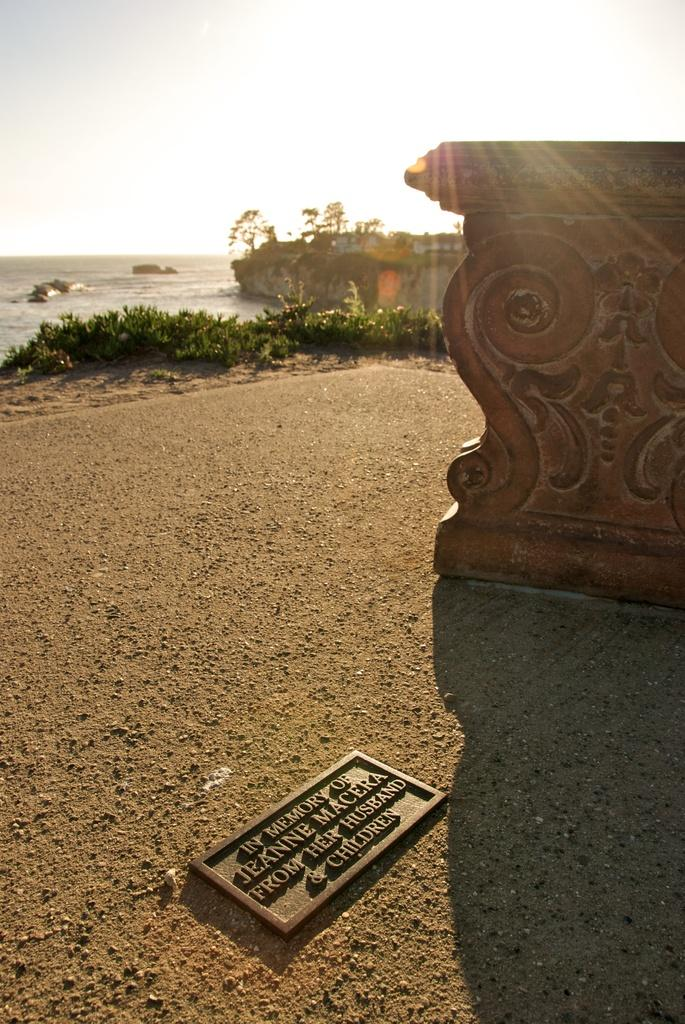What is on the ground in the image? There is a board on the ground in the image. What can be seen in the background of the image? The sky is sunny and visible in the background of the image. What type of vegetation is present in the image? There are plants in the image. What else can be seen in the image besides the board and plants? There is a wall, water, and stones visible in the image. What type of gun is being used by the plant in the image? There is no gun present in the image; it features a board, wall, plants, water, stones, and a sunny sky. How does the head of the stone appear in the image? There is no head present in the image, as stones do not have heads. 